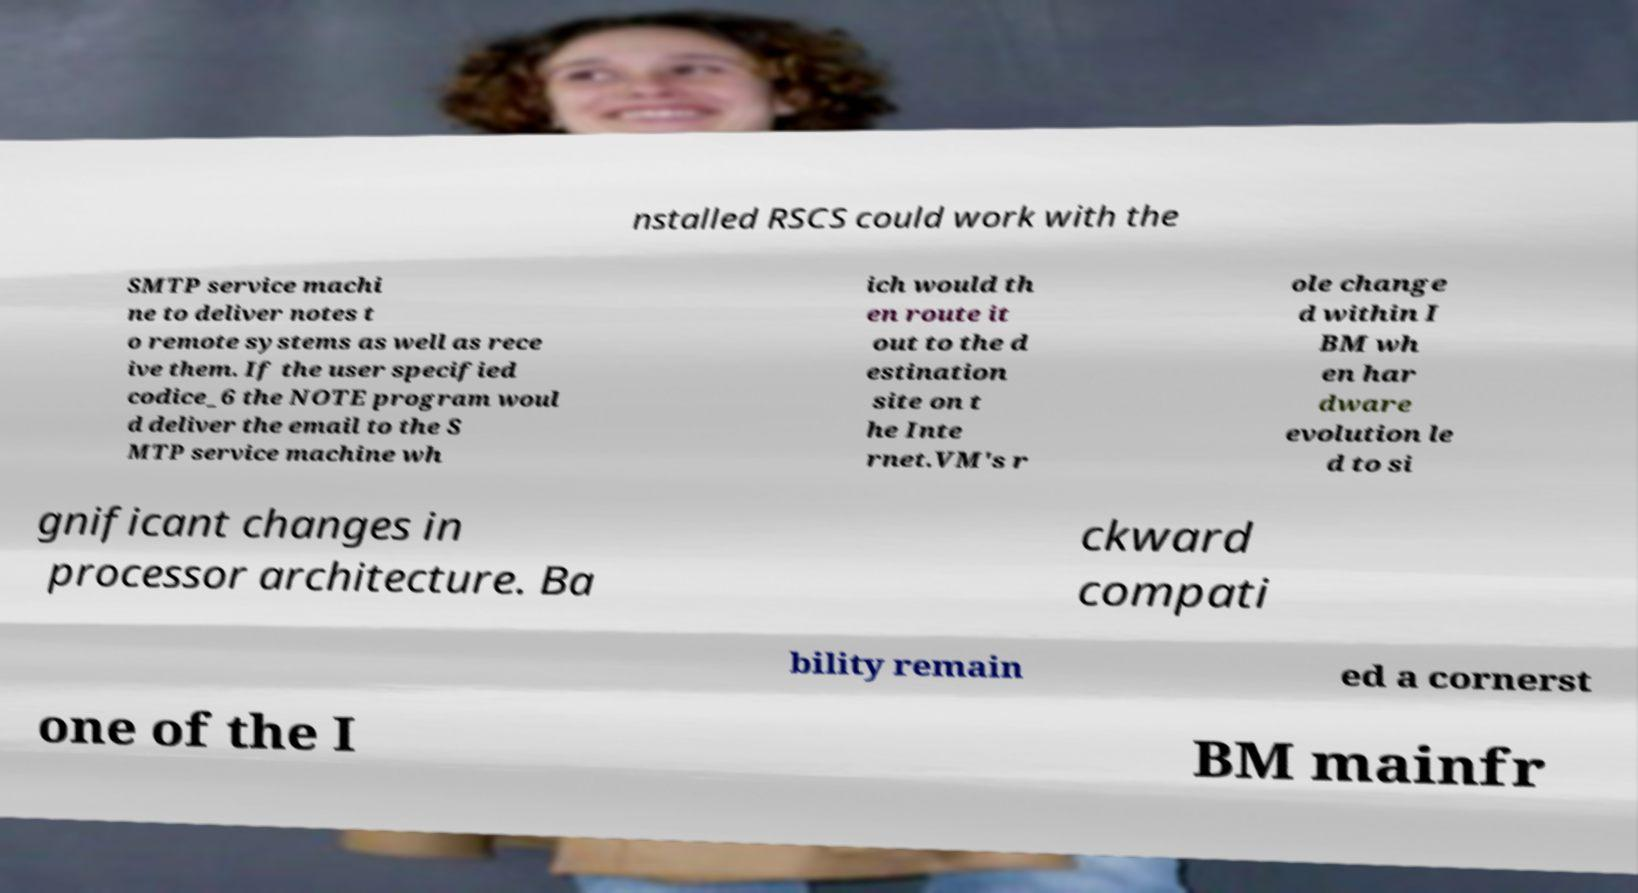Can you accurately transcribe the text from the provided image for me? nstalled RSCS could work with the SMTP service machi ne to deliver notes t o remote systems as well as rece ive them. If the user specified codice_6 the NOTE program woul d deliver the email to the S MTP service machine wh ich would th en route it out to the d estination site on t he Inte rnet.VM's r ole change d within I BM wh en har dware evolution le d to si gnificant changes in processor architecture. Ba ckward compati bility remain ed a cornerst one of the I BM mainfr 